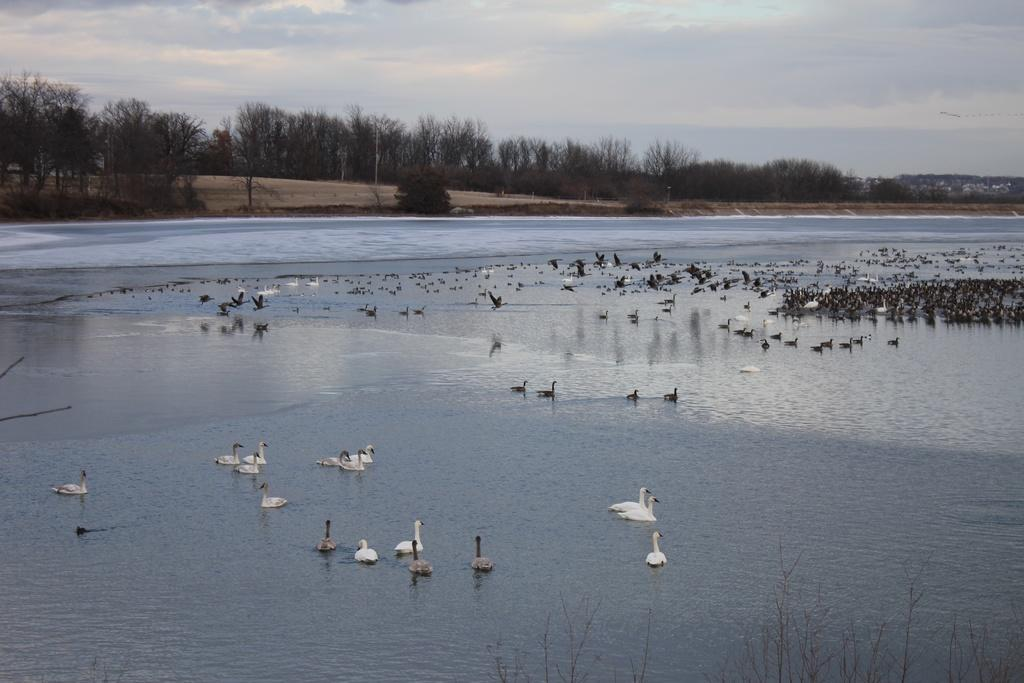What is happening with the birds in the image? There are birds on the water, and some birds are flying in the air. What can be seen in the background of the image? There are trees and poles in the background, as well as a house on the left side of the image. What is visible in the sky? There are clouds in the sky. What word does the father use to describe the birds in the image? There is no father present in the image, and therefore no such interaction can be observed. 